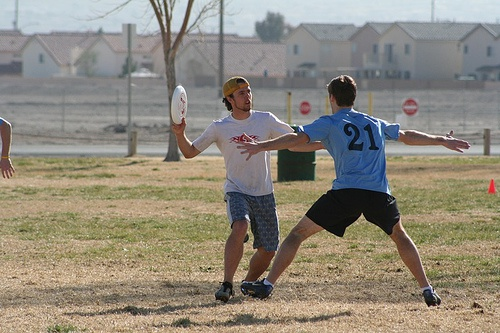Describe the objects in this image and their specific colors. I can see people in lightblue, black, blue, and gray tones, people in lightblue, gray, black, and maroon tones, people in lightblue, brown, maroon, darkgray, and tan tones, frisbee in lightblue, darkgray, lightgray, and gray tones, and stop sign in lightblue, brown, and gray tones in this image. 